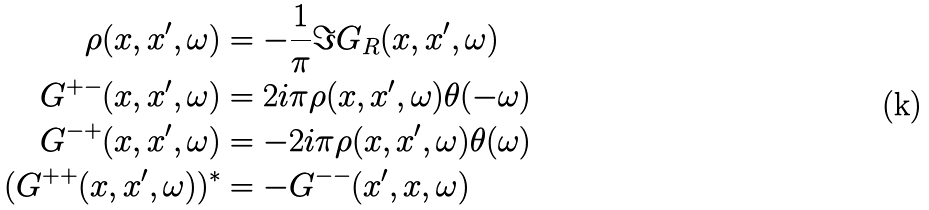<formula> <loc_0><loc_0><loc_500><loc_500>\rho ( x , x ^ { \prime } , \omega ) & = - \frac { 1 } { \pi } \Im G _ { R } ( x , x ^ { \prime } , \omega ) \\ G ^ { + - } ( x , x ^ { \prime } , \omega ) & = 2 i \pi \rho ( x , x ^ { \prime } , \omega ) \theta ( - \omega ) \\ G ^ { - + } ( x , x ^ { \prime } , \omega ) & = - 2 i \pi \rho ( x , x ^ { \prime } , \omega ) \theta ( \omega ) \\ ( G ^ { + + } ( x , x ^ { \prime } , \omega ) ) ^ { * } & = - G ^ { - - } ( x ^ { \prime } , x , \omega )</formula> 